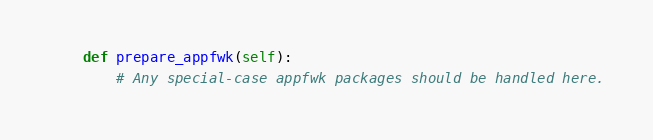<code> <loc_0><loc_0><loc_500><loc_500><_Python_>    def prepare_appfwk(self):
        # Any special-case appfwk packages should be handled here.
</code> 